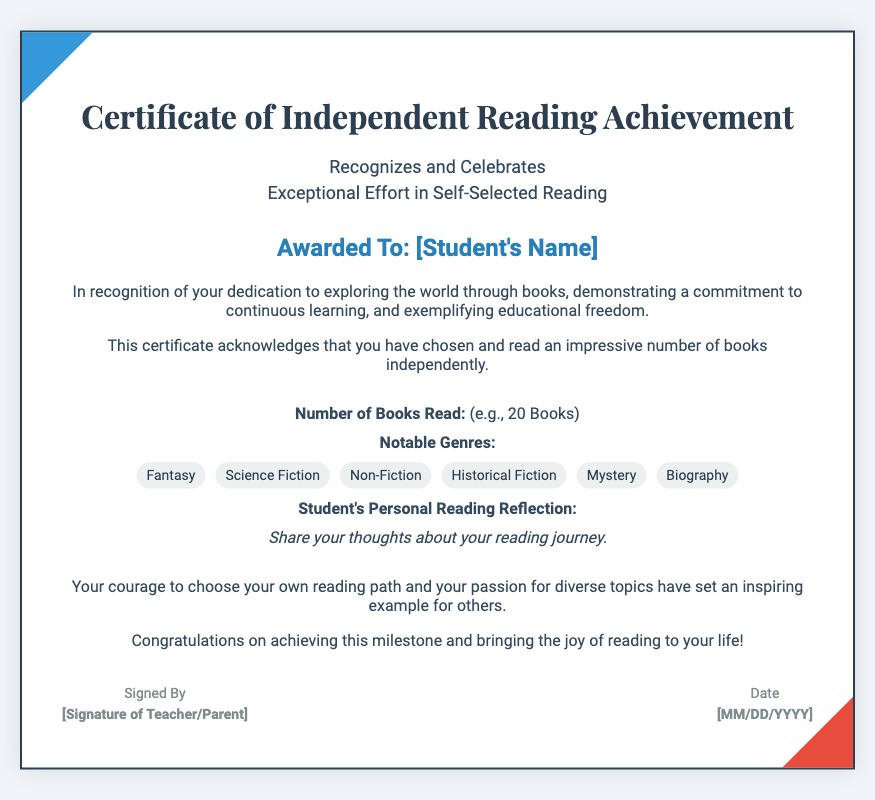What is the title of the certificate? The title of the certificate is prominently displayed at the top of the document, stating its purpose.
Answer: Certificate of Independent Reading Achievement Who is the certificate awarded to? The student's name is specifically mentioned in a designated section of the document.
Answer: [Student's Name] How many books has the student read? The document includes a specific section that quantifies the student's reading achievement in terms of books read.
Answer: [e.g., 20 Books] What genres are listed in the certificate? The certificate includes a section that highlights various genres that the student has explored through reading.
Answer: Fantasy, Science Fiction, Non-Fiction, Historical Fiction, Mystery, Biography What does the student's personal reading reflection section ask for? The certificate includes a prompt that encourages the student to express their thoughts on their reading journey.
Answer: Share your thoughts about your reading journey What does the acknowledgment section commend the student for? The acknowledgment section highlights the student's courage and passion in choosing their own reading path.
Answer: Educational freedom Who signs the certificate? There is a designated section for the signature of the person who recognizes the student's achievement.
Answer: [Signature of Teacher/Parent] What date is included in the certificate? The document includes a section where the date of the certificate issuance is noted.
Answer: [MM/DD/YYYY] 